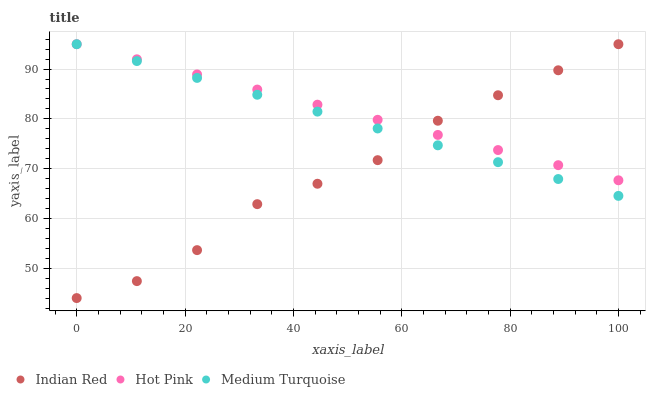Does Indian Red have the minimum area under the curve?
Answer yes or no. Yes. Does Hot Pink have the maximum area under the curve?
Answer yes or no. Yes. Does Medium Turquoise have the minimum area under the curve?
Answer yes or no. No. Does Medium Turquoise have the maximum area under the curve?
Answer yes or no. No. Is Hot Pink the smoothest?
Answer yes or no. Yes. Is Indian Red the roughest?
Answer yes or no. Yes. Is Medium Turquoise the smoothest?
Answer yes or no. No. Is Medium Turquoise the roughest?
Answer yes or no. No. Does Indian Red have the lowest value?
Answer yes or no. Yes. Does Medium Turquoise have the lowest value?
Answer yes or no. No. Does Indian Red have the highest value?
Answer yes or no. Yes. Does Hot Pink intersect Indian Red?
Answer yes or no. Yes. Is Hot Pink less than Indian Red?
Answer yes or no. No. Is Hot Pink greater than Indian Red?
Answer yes or no. No. 